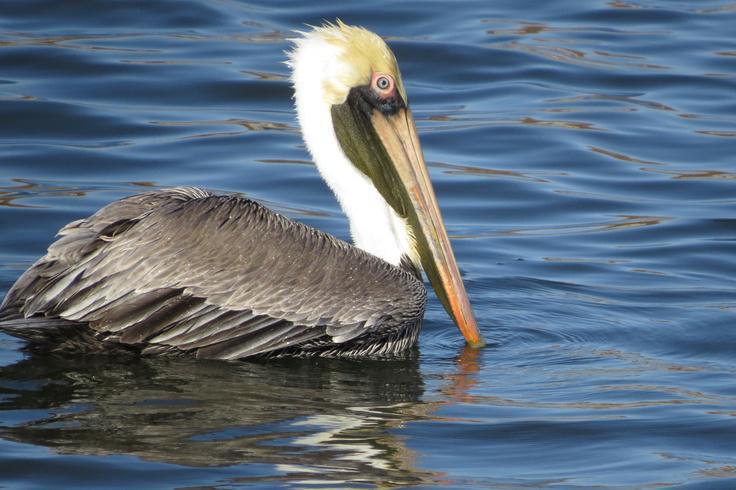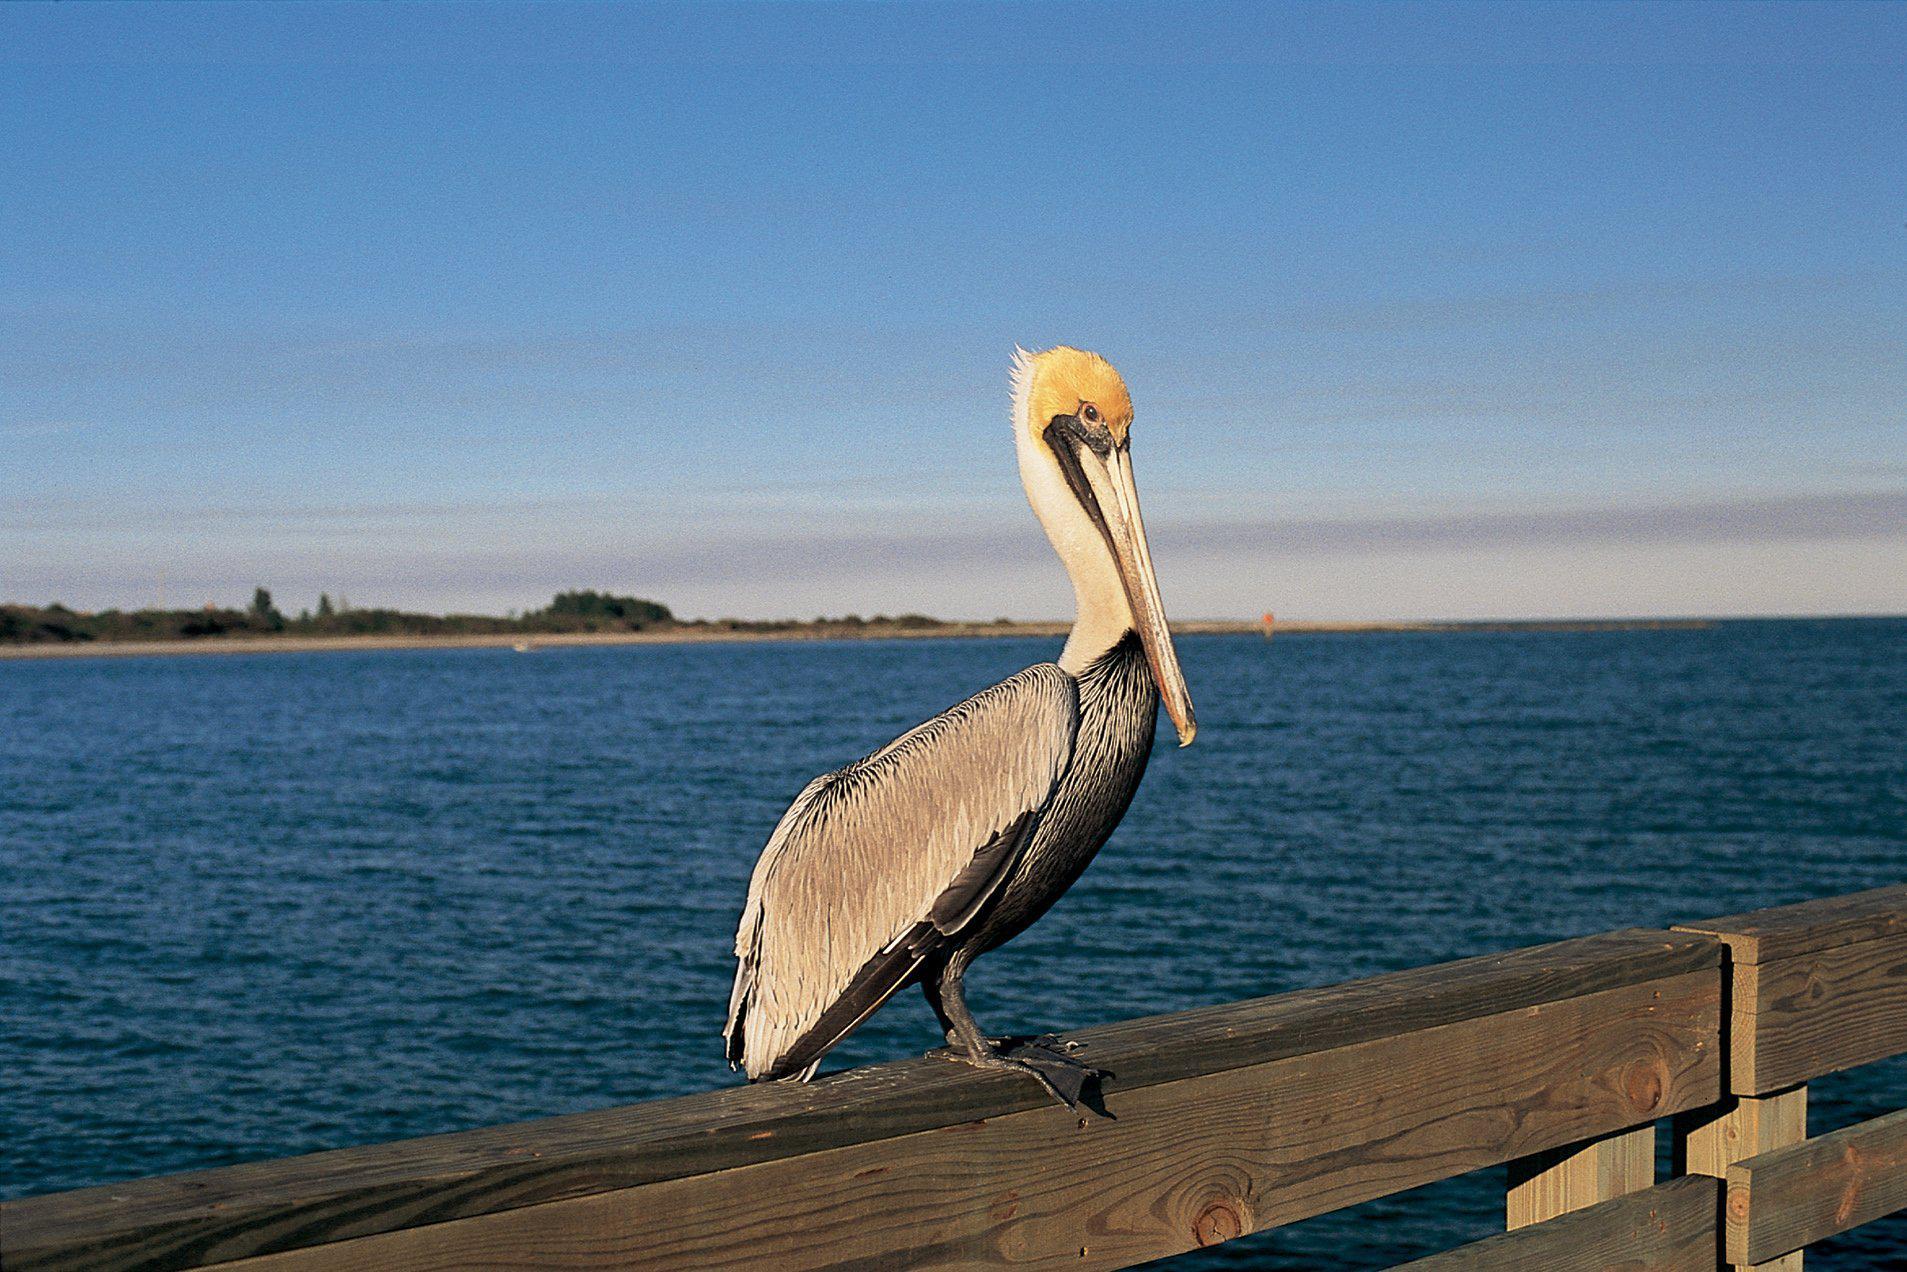The first image is the image on the left, the second image is the image on the right. Examine the images to the left and right. Is the description "In one of the images, there is a pelican in flight" accurate? Answer yes or no. No. 